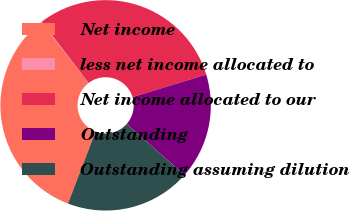Convert chart to OTSL. <chart><loc_0><loc_0><loc_500><loc_500><pie_chart><fcel>Net income<fcel>less net income allocated to<fcel>Net income allocated to our<fcel>Outstanding<fcel>Outstanding assuming dilution<nl><fcel>33.73%<fcel>0.07%<fcel>30.66%<fcel>16.24%<fcel>19.3%<nl></chart> 